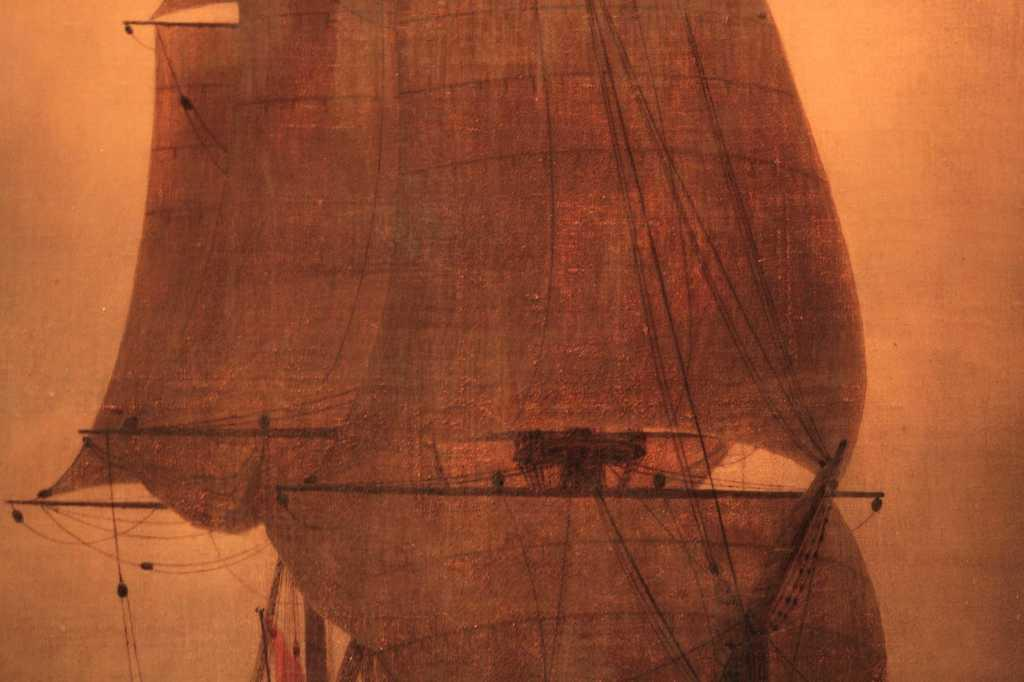What type of image is shown in the picture? The image is a picture of an art. What subject matter is depicted in the art? The art depicts a ship. How many chickens are present in the art? There are no chickens depicted in the art; it features a ship. 